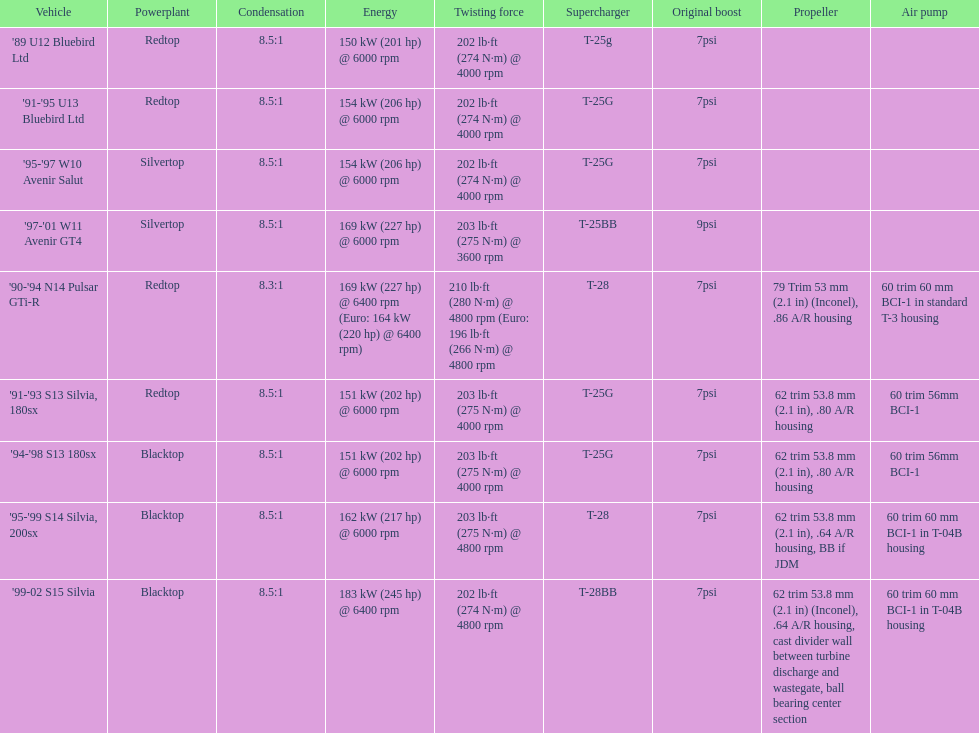Which engine(s) have the minimum power capacity? Redtop. 